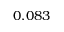<formula> <loc_0><loc_0><loc_500><loc_500>0 . 0 8 3</formula> 